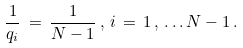Convert formula to latex. <formula><loc_0><loc_0><loc_500><loc_500>\frac { 1 } { q _ { i } } \, = \, \frac { 1 } { N - 1 } \, , \, i \, = \, 1 \, , \, . \, . \, . \, N - 1 \, .</formula> 